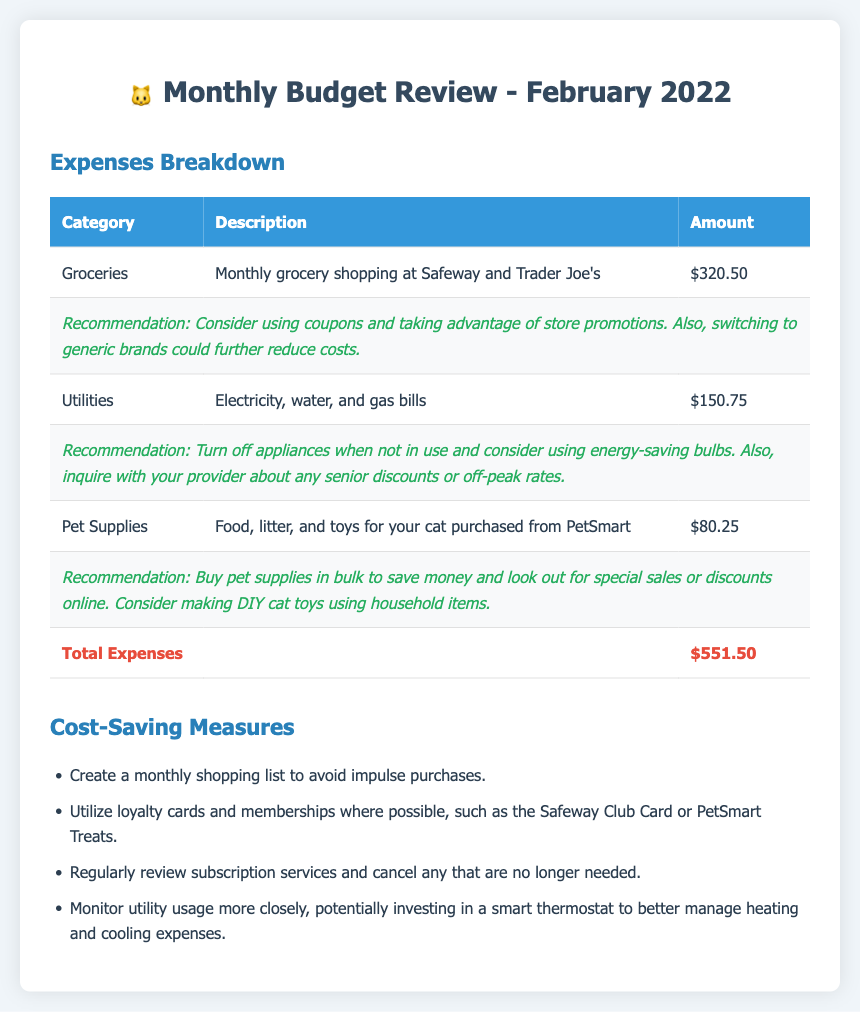What is the total amount spent on groceries? The total amount spent on groceries is listed as $320.50 in the expenses breakdown.
Answer: $320.50 What is the total amount spent on utilities? The total amount spent on utilities, which includes electricity, water, and gas bills, is $150.75.
Answer: $150.75 What is the total cost for pet supplies? The total cost for pet supplies, including food, litter, and toys, is provided as $80.25.
Answer: $80.25 What is the total of all expenses? The total expenses are calculated as $551.50, which is the sum of all categories listed.
Answer: $551.50 Which store did you buy groceries from? The document mentions that groceries were purchased at Safeway and Trader Joe's.
Answer: Safeway and Trader Joe's What cost-saving measure involves loyalty cards? Utilizing loyalty cards and memberships is suggested to save money on purchases.
Answer: Loyalty cards What type of bulbs are recommended for energy saving? The recommendation includes using energy-saving bulbs to reduce utility costs.
Answer: Energy-saving bulbs What should you inquire about regarding utility bills? It's recommended to inquire with the provider about any senior discounts or off-peak rates to potentially reduce costs.
Answer: Senior discounts What is one suggestion for buying pet supplies? One suggestion provided is to buy pet supplies in bulk to save money.
Answer: Buy in bulk 